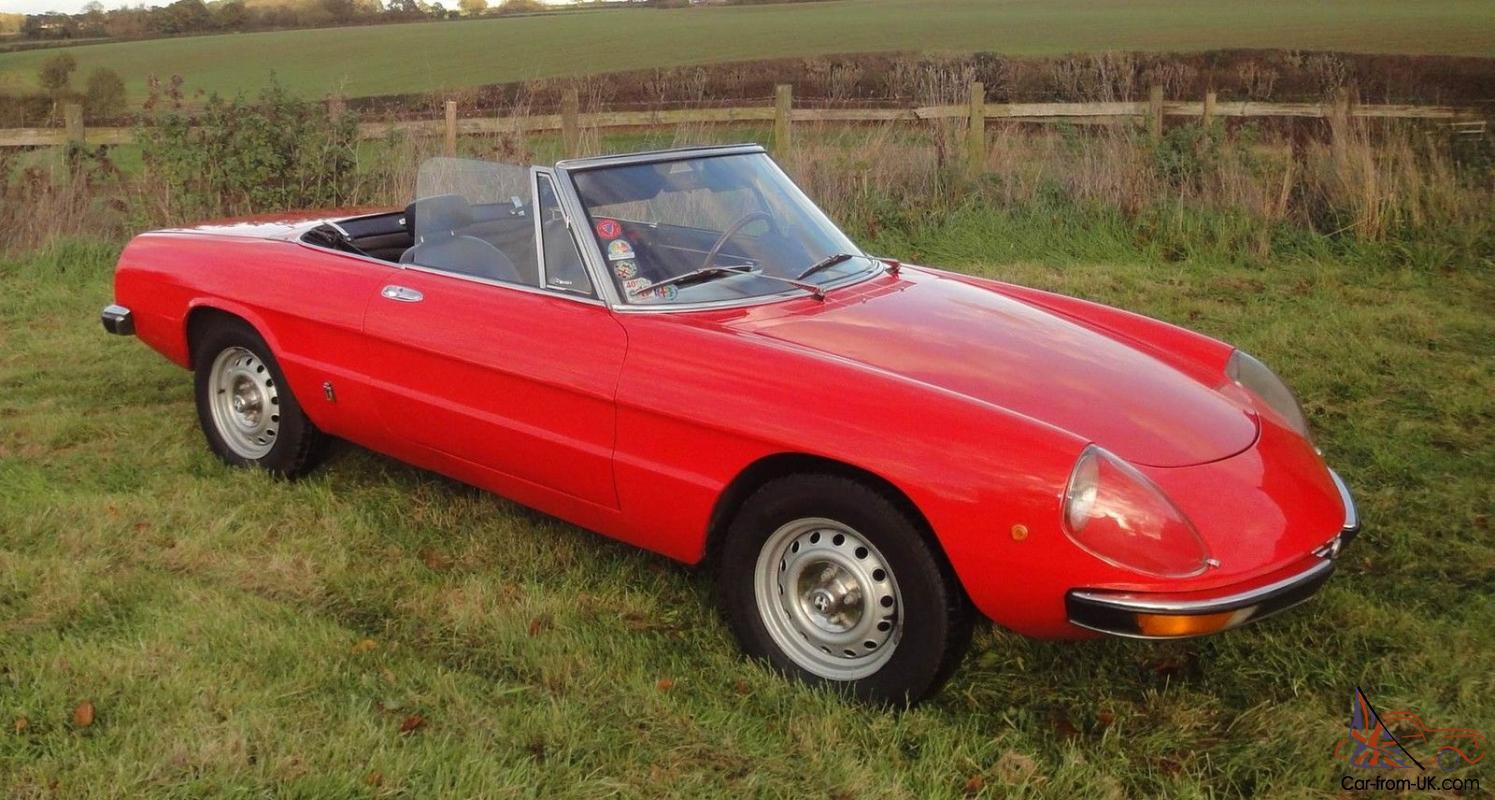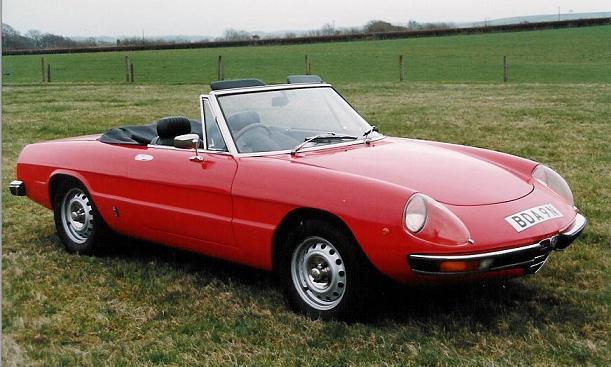The first image is the image on the left, the second image is the image on the right. Considering the images on both sides, is "The left image shows a driver behind the wheel of a topless red convertible." valid? Answer yes or no. No. The first image is the image on the left, the second image is the image on the right. Assess this claim about the two images: "Two sporty red convertibles with chrome wheels are angled in different directions, only one with a front license plate and driver.". Correct or not? Answer yes or no. No. 